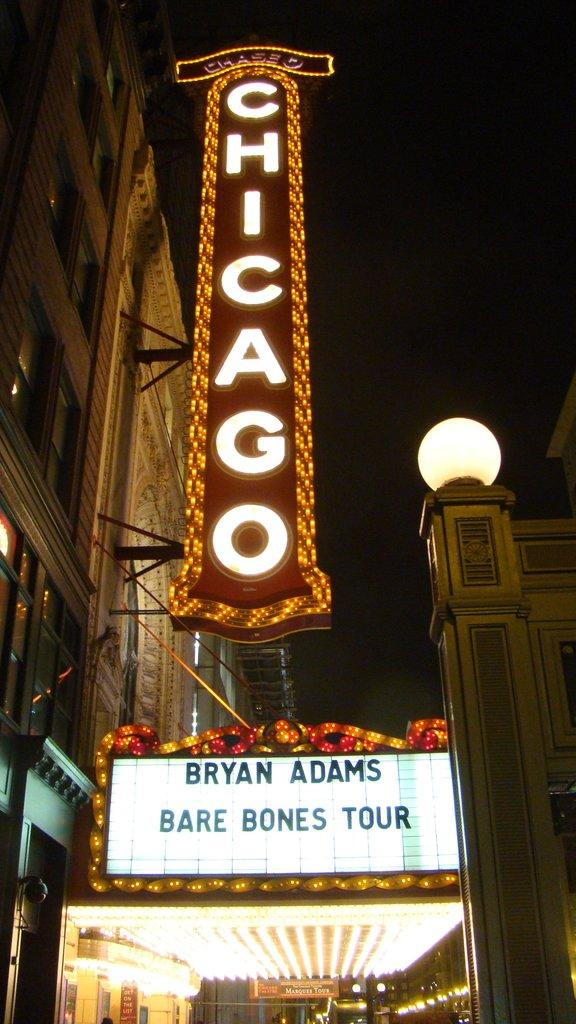What type of establishment is shown in the image? There is a shop in the image. What is hanging or displayed in the image? There is a banner in the image. Can you describe the left side of the image? The left side of the image features a building with lights on the banner board. How about the right side of the image? The right side of the image includes a wall with light. How does the shop contribute to the wealth of the community in the image? The image does not provide information about the shop's contribution to the community's wealth. 